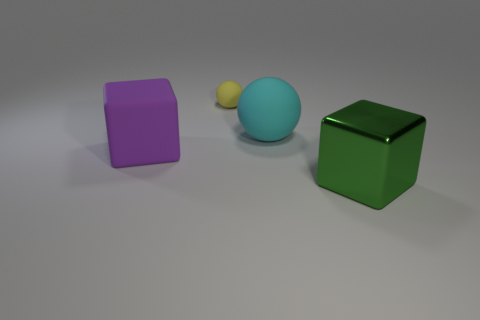Add 2 purple metal cubes. How many objects exist? 6 Subtract 1 spheres. How many spheres are left? 1 Subtract all green cubes. How many cubes are left? 1 Add 4 big green things. How many big green things are left? 5 Add 3 small green matte things. How many small green matte things exist? 3 Subtract 0 cyan cubes. How many objects are left? 4 Subtract all green balls. Subtract all gray blocks. How many balls are left? 2 Subtract all rubber balls. Subtract all yellow matte objects. How many objects are left? 1 